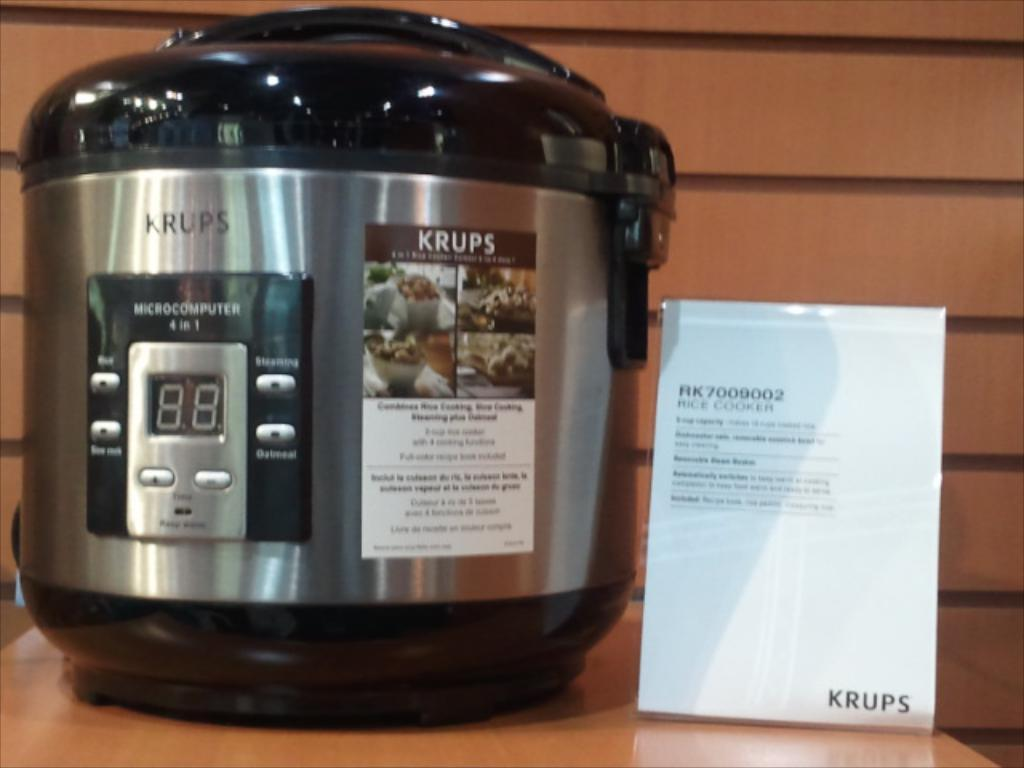<image>
Render a clear and concise summary of the photo. A pressure cooker made by Krups that has a MicroComputer 4 in 1. 